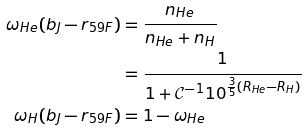Convert formula to latex. <formula><loc_0><loc_0><loc_500><loc_500>\omega _ { H e } ( b _ { J } - r _ { 5 9 F } ) & = \frac { n _ { H e } } { n _ { H e } + n _ { H } } \\ & = \frac { 1 } { 1 + \mathcal { C } ^ { - 1 } 1 0 ^ { \frac { 3 } { 5 } ( R _ { H e } - R _ { H } ) } } \\ \omega _ { H } ( b _ { J } - r _ { 5 9 F } ) & = 1 - \omega _ { H e }</formula> 